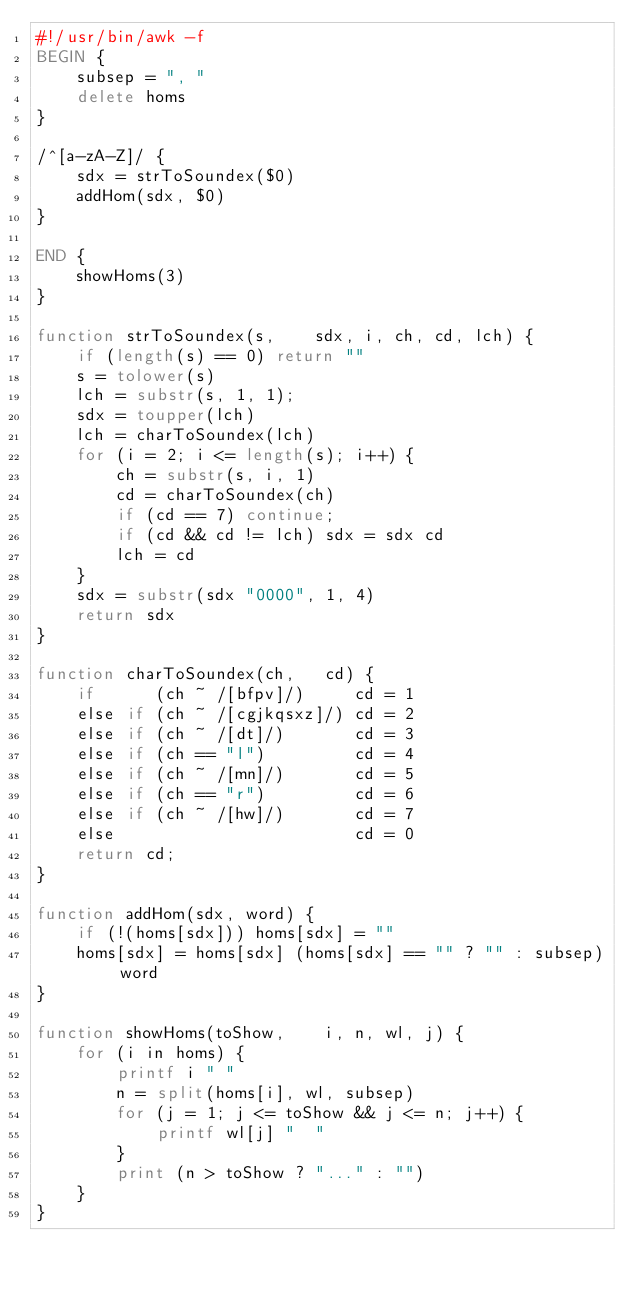<code> <loc_0><loc_0><loc_500><loc_500><_Awk_>#!/usr/bin/awk -f
BEGIN {
    subsep = ", "
    delete homs
}

/^[a-zA-Z]/ {
    sdx = strToSoundex($0)
    addHom(sdx, $0)
}

END {
    showHoms(3)
}

function strToSoundex(s,    sdx, i, ch, cd, lch) {
    if (length(s) == 0) return ""
    s = tolower(s)
    lch = substr(s, 1, 1);
    sdx = toupper(lch)
    lch = charToSoundex(lch)
    for (i = 2; i <= length(s); i++) {
        ch = substr(s, i, 1)
        cd = charToSoundex(ch)
        if (cd == 7) continue;
        if (cd && cd != lch) sdx = sdx cd
        lch = cd
    }
    sdx = substr(sdx "0000", 1, 4)
    return sdx
}

function charToSoundex(ch,   cd) {
    if      (ch ~ /[bfpv]/)     cd = 1
    else if (ch ~ /[cgjkqsxz]/) cd = 2
    else if (ch ~ /[dt]/)       cd = 3
    else if (ch == "l")         cd = 4
    else if (ch ~ /[mn]/)       cd = 5
    else if (ch == "r")         cd = 6
    else if (ch ~ /[hw]/)       cd = 7
    else                        cd = 0
    return cd;
}

function addHom(sdx, word) {
    if (!(homs[sdx])) homs[sdx] = ""
    homs[sdx] = homs[sdx] (homs[sdx] == "" ? "" : subsep) word
}

function showHoms(toShow,    i, n, wl, j) {
    for (i in homs) {
        printf i " "
        n = split(homs[i], wl, subsep)
        for (j = 1; j <= toShow && j <= n; j++) {
            printf wl[j] "  "
        }
        print (n > toShow ? "..." : "")
    }
}
</code> 